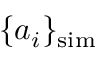Convert formula to latex. <formula><loc_0><loc_0><loc_500><loc_500>\{ a _ { i } \} _ { s i m }</formula> 